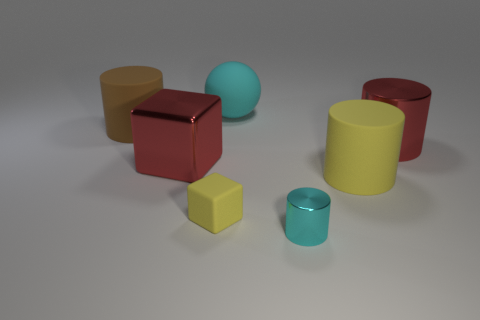Is there anything else that has the same shape as the big cyan rubber thing?
Provide a succinct answer. No. What is the color of the rubber thing on the right side of the tiny thing in front of the small object behind the tiny cyan metal object?
Ensure brevity in your answer.  Yellow. The big shiny cube has what color?
Give a very brief answer. Red. Is the number of red shiny blocks to the right of the large cube greater than the number of brown rubber things that are in front of the large brown object?
Provide a succinct answer. No. Is the shape of the small cyan object the same as the big red object that is on the right side of the red block?
Provide a succinct answer. Yes. Does the red object that is on the right side of the metal block have the same size as the cyan object that is on the left side of the cyan cylinder?
Offer a terse response. Yes. There is a red shiny object on the right side of the cyan object that is in front of the brown cylinder; is there a big brown matte cylinder that is in front of it?
Ensure brevity in your answer.  No. Are there fewer brown things in front of the red shiny cylinder than small cyan cylinders that are to the left of the large cyan sphere?
Your answer should be very brief. No. There is a big yellow object that is made of the same material as the brown cylinder; what shape is it?
Make the answer very short. Cylinder. What is the size of the red metal thing to the left of the cylinder that is right of the big cylinder that is in front of the large red cube?
Offer a very short reply. Large. 